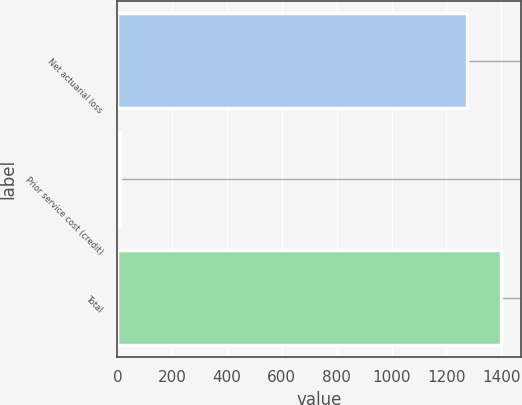Convert chart. <chart><loc_0><loc_0><loc_500><loc_500><bar_chart><fcel>Net actuarial loss<fcel>Prior service cost (credit)<fcel>Total<nl><fcel>1273.6<fcel>8.5<fcel>1400.96<nl></chart> 